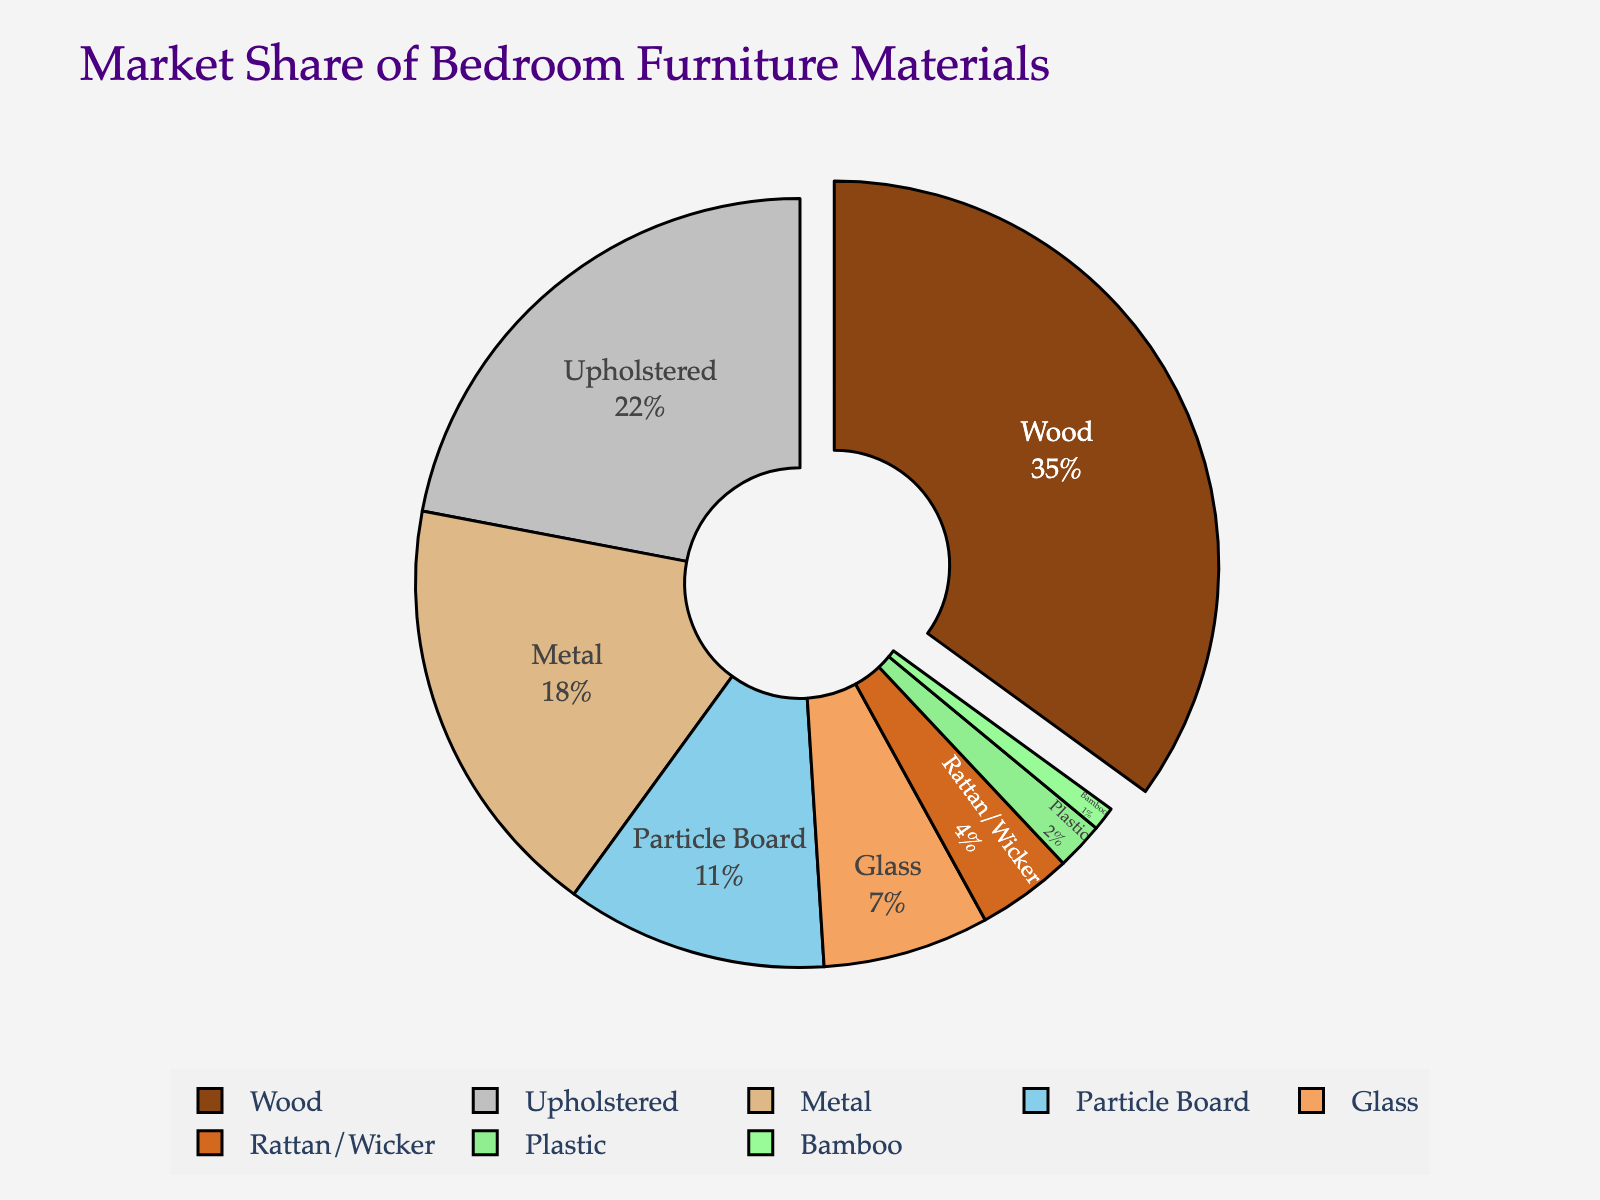What is the most common material used for bedroom furniture according to the chart? The chart shows a pie slice with a greater percentage and highlighted pull for "Wood," indicating it is the most common material.
Answer: Wood Which material has a larger market share, Metal or Upholstered? The slice for Upholstered is larger than the slice for Metal in the pie chart.
Answer: Upholstered What is the total market share of materials that individually constitute less than 10% of the market? The materials with less than 10% each are Glass (7%), Rattan/Wicker (4%), Plastic (2%), and Bamboo (1%). Adding them up: 7 + 4 + 2 + 1 = 14%
Answer: 14% How much larger is the market share of Wood compared to Metal? The chart shows Wood at 35% and Metal at 18%. The difference is 35 - 18 = 17%.
Answer: 17% Which material has the smallest market share, and what is its percentage? The smallest slice in the pie chart is labeled "Bamboo," with a percentage of 1%.
Answer: Bamboo, 1% What percentage of the market do Wood and Upholstered materials together represent? Wood has 35% and Upholstered has 22%. Together, they constitute 35 + 22 = 57%.
Answer: 57% By how much is the market share of Particle Board greater than that of Rattan/Wicker? Particle Board has 11% and Rattan/Wicker has 4%. The difference is 11 - 4 = 7%.
Answer: 7% What is the combined market share of Metal, Upholstered, and Particle Board? Metal has 18%, Upholstered has 22%, and Particle Board has 11%. Adding them up: 18 + 22 + 11 = 51%.
Answer: 51% How does the market share of Glass compare to that of Particle Board? Glass has a market share of 7%, and Particle Board has 11%. Glass has a smaller share by 4%.
Answer: 4% smaller What percentage of the market is covered by materials other than Wood and Upholstered? Wood and Upholstered together make up 35% + 22% = 57%. Therefore, the remaining materials cover 100% - 57% = 43%.
Answer: 43% 